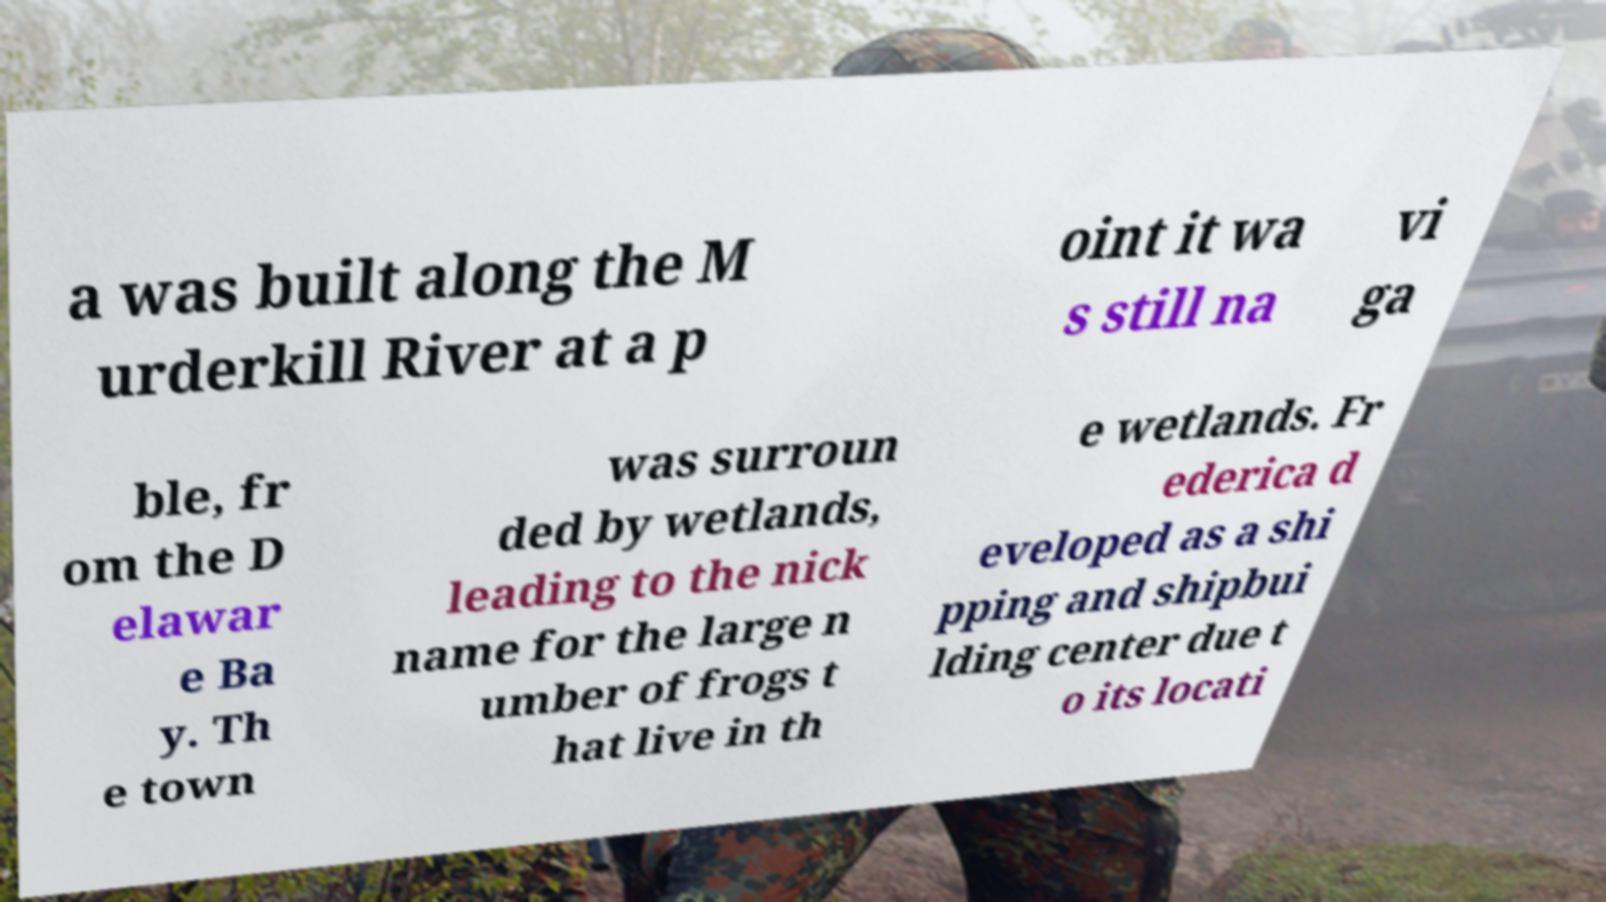For documentation purposes, I need the text within this image transcribed. Could you provide that? a was built along the M urderkill River at a p oint it wa s still na vi ga ble, fr om the D elawar e Ba y. Th e town was surroun ded by wetlands, leading to the nick name for the large n umber of frogs t hat live in th e wetlands. Fr ederica d eveloped as a shi pping and shipbui lding center due t o its locati 